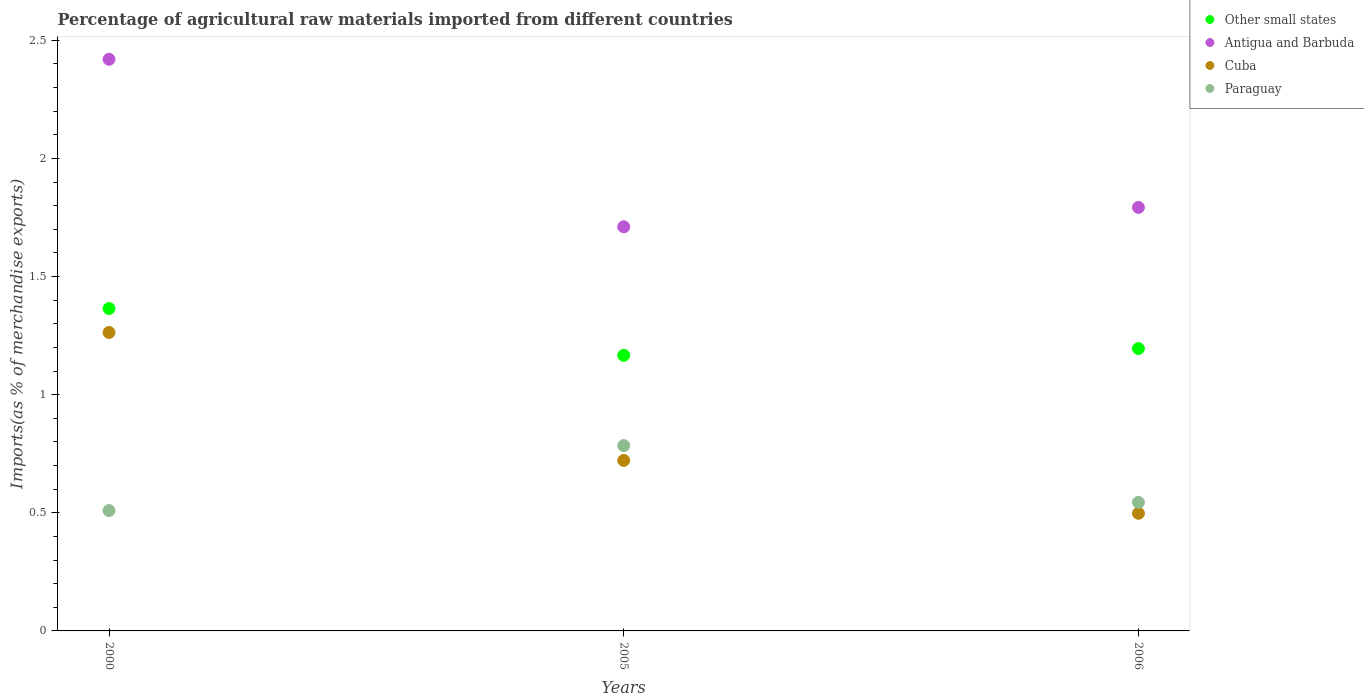How many different coloured dotlines are there?
Ensure brevity in your answer.  4. Is the number of dotlines equal to the number of legend labels?
Provide a succinct answer. Yes. What is the percentage of imports to different countries in Paraguay in 2005?
Give a very brief answer. 0.78. Across all years, what is the maximum percentage of imports to different countries in Antigua and Barbuda?
Make the answer very short. 2.42. Across all years, what is the minimum percentage of imports to different countries in Antigua and Barbuda?
Your response must be concise. 1.71. In which year was the percentage of imports to different countries in Antigua and Barbuda minimum?
Your answer should be very brief. 2005. What is the total percentage of imports to different countries in Cuba in the graph?
Provide a short and direct response. 2.48. What is the difference between the percentage of imports to different countries in Antigua and Barbuda in 2000 and that in 2005?
Ensure brevity in your answer.  0.71. What is the difference between the percentage of imports to different countries in Cuba in 2006 and the percentage of imports to different countries in Other small states in 2000?
Give a very brief answer. -0.87. What is the average percentage of imports to different countries in Paraguay per year?
Ensure brevity in your answer.  0.61. In the year 2006, what is the difference between the percentage of imports to different countries in Cuba and percentage of imports to different countries in Antigua and Barbuda?
Give a very brief answer. -1.29. In how many years, is the percentage of imports to different countries in Paraguay greater than 1.1 %?
Your answer should be very brief. 0. What is the ratio of the percentage of imports to different countries in Other small states in 2000 to that in 2005?
Keep it short and to the point. 1.17. Is the percentage of imports to different countries in Other small states in 2000 less than that in 2006?
Your answer should be compact. No. What is the difference between the highest and the second highest percentage of imports to different countries in Antigua and Barbuda?
Provide a short and direct response. 0.63. What is the difference between the highest and the lowest percentage of imports to different countries in Paraguay?
Give a very brief answer. 0.28. Is it the case that in every year, the sum of the percentage of imports to different countries in Cuba and percentage of imports to different countries in Antigua and Barbuda  is greater than the sum of percentage of imports to different countries in Other small states and percentage of imports to different countries in Paraguay?
Offer a terse response. No. Is it the case that in every year, the sum of the percentage of imports to different countries in Cuba and percentage of imports to different countries in Other small states  is greater than the percentage of imports to different countries in Antigua and Barbuda?
Your response must be concise. No. Is the percentage of imports to different countries in Paraguay strictly greater than the percentage of imports to different countries in Cuba over the years?
Your answer should be very brief. No. How many dotlines are there?
Provide a succinct answer. 4. How many years are there in the graph?
Provide a succinct answer. 3. Where does the legend appear in the graph?
Offer a terse response. Top right. What is the title of the graph?
Your answer should be compact. Percentage of agricultural raw materials imported from different countries. What is the label or title of the Y-axis?
Provide a succinct answer. Imports(as % of merchandise exports). What is the Imports(as % of merchandise exports) of Other small states in 2000?
Offer a terse response. 1.36. What is the Imports(as % of merchandise exports) of Antigua and Barbuda in 2000?
Your answer should be compact. 2.42. What is the Imports(as % of merchandise exports) of Cuba in 2000?
Your answer should be very brief. 1.26. What is the Imports(as % of merchandise exports) of Paraguay in 2000?
Your response must be concise. 0.51. What is the Imports(as % of merchandise exports) in Other small states in 2005?
Offer a very short reply. 1.17. What is the Imports(as % of merchandise exports) in Antigua and Barbuda in 2005?
Provide a short and direct response. 1.71. What is the Imports(as % of merchandise exports) in Cuba in 2005?
Your response must be concise. 0.72. What is the Imports(as % of merchandise exports) of Paraguay in 2005?
Provide a succinct answer. 0.78. What is the Imports(as % of merchandise exports) of Other small states in 2006?
Provide a succinct answer. 1.2. What is the Imports(as % of merchandise exports) of Antigua and Barbuda in 2006?
Offer a terse response. 1.79. What is the Imports(as % of merchandise exports) in Cuba in 2006?
Ensure brevity in your answer.  0.5. What is the Imports(as % of merchandise exports) of Paraguay in 2006?
Give a very brief answer. 0.54. Across all years, what is the maximum Imports(as % of merchandise exports) of Other small states?
Your response must be concise. 1.36. Across all years, what is the maximum Imports(as % of merchandise exports) of Antigua and Barbuda?
Provide a succinct answer. 2.42. Across all years, what is the maximum Imports(as % of merchandise exports) of Cuba?
Make the answer very short. 1.26. Across all years, what is the maximum Imports(as % of merchandise exports) in Paraguay?
Ensure brevity in your answer.  0.78. Across all years, what is the minimum Imports(as % of merchandise exports) in Other small states?
Your answer should be very brief. 1.17. Across all years, what is the minimum Imports(as % of merchandise exports) in Antigua and Barbuda?
Make the answer very short. 1.71. Across all years, what is the minimum Imports(as % of merchandise exports) of Cuba?
Provide a short and direct response. 0.5. Across all years, what is the minimum Imports(as % of merchandise exports) of Paraguay?
Provide a succinct answer. 0.51. What is the total Imports(as % of merchandise exports) in Other small states in the graph?
Keep it short and to the point. 3.73. What is the total Imports(as % of merchandise exports) in Antigua and Barbuda in the graph?
Your answer should be very brief. 5.92. What is the total Imports(as % of merchandise exports) in Cuba in the graph?
Give a very brief answer. 2.48. What is the total Imports(as % of merchandise exports) in Paraguay in the graph?
Give a very brief answer. 1.84. What is the difference between the Imports(as % of merchandise exports) of Other small states in 2000 and that in 2005?
Provide a succinct answer. 0.2. What is the difference between the Imports(as % of merchandise exports) of Antigua and Barbuda in 2000 and that in 2005?
Offer a very short reply. 0.71. What is the difference between the Imports(as % of merchandise exports) in Cuba in 2000 and that in 2005?
Provide a short and direct response. 0.54. What is the difference between the Imports(as % of merchandise exports) of Paraguay in 2000 and that in 2005?
Your answer should be very brief. -0.28. What is the difference between the Imports(as % of merchandise exports) of Other small states in 2000 and that in 2006?
Offer a very short reply. 0.17. What is the difference between the Imports(as % of merchandise exports) in Antigua and Barbuda in 2000 and that in 2006?
Offer a very short reply. 0.63. What is the difference between the Imports(as % of merchandise exports) of Cuba in 2000 and that in 2006?
Keep it short and to the point. 0.77. What is the difference between the Imports(as % of merchandise exports) in Paraguay in 2000 and that in 2006?
Make the answer very short. -0.03. What is the difference between the Imports(as % of merchandise exports) of Other small states in 2005 and that in 2006?
Provide a short and direct response. -0.03. What is the difference between the Imports(as % of merchandise exports) in Antigua and Barbuda in 2005 and that in 2006?
Your answer should be compact. -0.08. What is the difference between the Imports(as % of merchandise exports) of Cuba in 2005 and that in 2006?
Offer a very short reply. 0.22. What is the difference between the Imports(as % of merchandise exports) in Paraguay in 2005 and that in 2006?
Provide a succinct answer. 0.24. What is the difference between the Imports(as % of merchandise exports) of Other small states in 2000 and the Imports(as % of merchandise exports) of Antigua and Barbuda in 2005?
Provide a succinct answer. -0.35. What is the difference between the Imports(as % of merchandise exports) in Other small states in 2000 and the Imports(as % of merchandise exports) in Cuba in 2005?
Your response must be concise. 0.64. What is the difference between the Imports(as % of merchandise exports) in Other small states in 2000 and the Imports(as % of merchandise exports) in Paraguay in 2005?
Provide a succinct answer. 0.58. What is the difference between the Imports(as % of merchandise exports) of Antigua and Barbuda in 2000 and the Imports(as % of merchandise exports) of Cuba in 2005?
Offer a very short reply. 1.7. What is the difference between the Imports(as % of merchandise exports) in Antigua and Barbuda in 2000 and the Imports(as % of merchandise exports) in Paraguay in 2005?
Make the answer very short. 1.64. What is the difference between the Imports(as % of merchandise exports) in Cuba in 2000 and the Imports(as % of merchandise exports) in Paraguay in 2005?
Make the answer very short. 0.48. What is the difference between the Imports(as % of merchandise exports) in Other small states in 2000 and the Imports(as % of merchandise exports) in Antigua and Barbuda in 2006?
Make the answer very short. -0.43. What is the difference between the Imports(as % of merchandise exports) in Other small states in 2000 and the Imports(as % of merchandise exports) in Cuba in 2006?
Provide a short and direct response. 0.87. What is the difference between the Imports(as % of merchandise exports) of Other small states in 2000 and the Imports(as % of merchandise exports) of Paraguay in 2006?
Give a very brief answer. 0.82. What is the difference between the Imports(as % of merchandise exports) of Antigua and Barbuda in 2000 and the Imports(as % of merchandise exports) of Cuba in 2006?
Your answer should be very brief. 1.92. What is the difference between the Imports(as % of merchandise exports) of Antigua and Barbuda in 2000 and the Imports(as % of merchandise exports) of Paraguay in 2006?
Keep it short and to the point. 1.88. What is the difference between the Imports(as % of merchandise exports) of Cuba in 2000 and the Imports(as % of merchandise exports) of Paraguay in 2006?
Make the answer very short. 0.72. What is the difference between the Imports(as % of merchandise exports) in Other small states in 2005 and the Imports(as % of merchandise exports) in Antigua and Barbuda in 2006?
Offer a terse response. -0.63. What is the difference between the Imports(as % of merchandise exports) of Other small states in 2005 and the Imports(as % of merchandise exports) of Cuba in 2006?
Provide a succinct answer. 0.67. What is the difference between the Imports(as % of merchandise exports) in Other small states in 2005 and the Imports(as % of merchandise exports) in Paraguay in 2006?
Make the answer very short. 0.62. What is the difference between the Imports(as % of merchandise exports) in Antigua and Barbuda in 2005 and the Imports(as % of merchandise exports) in Cuba in 2006?
Offer a terse response. 1.21. What is the difference between the Imports(as % of merchandise exports) in Antigua and Barbuda in 2005 and the Imports(as % of merchandise exports) in Paraguay in 2006?
Offer a very short reply. 1.17. What is the difference between the Imports(as % of merchandise exports) in Cuba in 2005 and the Imports(as % of merchandise exports) in Paraguay in 2006?
Offer a very short reply. 0.18. What is the average Imports(as % of merchandise exports) in Other small states per year?
Offer a very short reply. 1.24. What is the average Imports(as % of merchandise exports) in Antigua and Barbuda per year?
Provide a succinct answer. 1.97. What is the average Imports(as % of merchandise exports) of Cuba per year?
Give a very brief answer. 0.83. What is the average Imports(as % of merchandise exports) of Paraguay per year?
Your response must be concise. 0.61. In the year 2000, what is the difference between the Imports(as % of merchandise exports) of Other small states and Imports(as % of merchandise exports) of Antigua and Barbuda?
Your response must be concise. -1.05. In the year 2000, what is the difference between the Imports(as % of merchandise exports) of Other small states and Imports(as % of merchandise exports) of Cuba?
Your response must be concise. 0.1. In the year 2000, what is the difference between the Imports(as % of merchandise exports) in Other small states and Imports(as % of merchandise exports) in Paraguay?
Provide a short and direct response. 0.86. In the year 2000, what is the difference between the Imports(as % of merchandise exports) in Antigua and Barbuda and Imports(as % of merchandise exports) in Cuba?
Offer a very short reply. 1.16. In the year 2000, what is the difference between the Imports(as % of merchandise exports) of Antigua and Barbuda and Imports(as % of merchandise exports) of Paraguay?
Your response must be concise. 1.91. In the year 2000, what is the difference between the Imports(as % of merchandise exports) of Cuba and Imports(as % of merchandise exports) of Paraguay?
Your answer should be compact. 0.75. In the year 2005, what is the difference between the Imports(as % of merchandise exports) of Other small states and Imports(as % of merchandise exports) of Antigua and Barbuda?
Give a very brief answer. -0.54. In the year 2005, what is the difference between the Imports(as % of merchandise exports) in Other small states and Imports(as % of merchandise exports) in Cuba?
Offer a very short reply. 0.44. In the year 2005, what is the difference between the Imports(as % of merchandise exports) in Other small states and Imports(as % of merchandise exports) in Paraguay?
Provide a short and direct response. 0.38. In the year 2005, what is the difference between the Imports(as % of merchandise exports) of Antigua and Barbuda and Imports(as % of merchandise exports) of Cuba?
Ensure brevity in your answer.  0.99. In the year 2005, what is the difference between the Imports(as % of merchandise exports) in Antigua and Barbuda and Imports(as % of merchandise exports) in Paraguay?
Offer a very short reply. 0.93. In the year 2005, what is the difference between the Imports(as % of merchandise exports) in Cuba and Imports(as % of merchandise exports) in Paraguay?
Offer a very short reply. -0.06. In the year 2006, what is the difference between the Imports(as % of merchandise exports) in Other small states and Imports(as % of merchandise exports) in Antigua and Barbuda?
Offer a terse response. -0.6. In the year 2006, what is the difference between the Imports(as % of merchandise exports) of Other small states and Imports(as % of merchandise exports) of Cuba?
Offer a terse response. 0.7. In the year 2006, what is the difference between the Imports(as % of merchandise exports) of Other small states and Imports(as % of merchandise exports) of Paraguay?
Your answer should be compact. 0.65. In the year 2006, what is the difference between the Imports(as % of merchandise exports) of Antigua and Barbuda and Imports(as % of merchandise exports) of Cuba?
Offer a terse response. 1.29. In the year 2006, what is the difference between the Imports(as % of merchandise exports) in Antigua and Barbuda and Imports(as % of merchandise exports) in Paraguay?
Provide a succinct answer. 1.25. In the year 2006, what is the difference between the Imports(as % of merchandise exports) of Cuba and Imports(as % of merchandise exports) of Paraguay?
Keep it short and to the point. -0.05. What is the ratio of the Imports(as % of merchandise exports) in Other small states in 2000 to that in 2005?
Give a very brief answer. 1.17. What is the ratio of the Imports(as % of merchandise exports) in Antigua and Barbuda in 2000 to that in 2005?
Keep it short and to the point. 1.41. What is the ratio of the Imports(as % of merchandise exports) in Cuba in 2000 to that in 2005?
Provide a short and direct response. 1.75. What is the ratio of the Imports(as % of merchandise exports) in Paraguay in 2000 to that in 2005?
Provide a succinct answer. 0.65. What is the ratio of the Imports(as % of merchandise exports) of Other small states in 2000 to that in 2006?
Give a very brief answer. 1.14. What is the ratio of the Imports(as % of merchandise exports) of Antigua and Barbuda in 2000 to that in 2006?
Provide a short and direct response. 1.35. What is the ratio of the Imports(as % of merchandise exports) in Cuba in 2000 to that in 2006?
Your answer should be compact. 2.54. What is the ratio of the Imports(as % of merchandise exports) of Paraguay in 2000 to that in 2006?
Give a very brief answer. 0.94. What is the ratio of the Imports(as % of merchandise exports) of Antigua and Barbuda in 2005 to that in 2006?
Provide a short and direct response. 0.95. What is the ratio of the Imports(as % of merchandise exports) of Cuba in 2005 to that in 2006?
Your answer should be very brief. 1.45. What is the ratio of the Imports(as % of merchandise exports) of Paraguay in 2005 to that in 2006?
Offer a very short reply. 1.44. What is the difference between the highest and the second highest Imports(as % of merchandise exports) in Other small states?
Your answer should be very brief. 0.17. What is the difference between the highest and the second highest Imports(as % of merchandise exports) in Antigua and Barbuda?
Your answer should be very brief. 0.63. What is the difference between the highest and the second highest Imports(as % of merchandise exports) in Cuba?
Offer a terse response. 0.54. What is the difference between the highest and the second highest Imports(as % of merchandise exports) of Paraguay?
Offer a very short reply. 0.24. What is the difference between the highest and the lowest Imports(as % of merchandise exports) of Other small states?
Provide a short and direct response. 0.2. What is the difference between the highest and the lowest Imports(as % of merchandise exports) in Antigua and Barbuda?
Offer a very short reply. 0.71. What is the difference between the highest and the lowest Imports(as % of merchandise exports) in Cuba?
Ensure brevity in your answer.  0.77. What is the difference between the highest and the lowest Imports(as % of merchandise exports) in Paraguay?
Offer a very short reply. 0.28. 